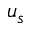Convert formula to latex. <formula><loc_0><loc_0><loc_500><loc_500>u _ { s }</formula> 